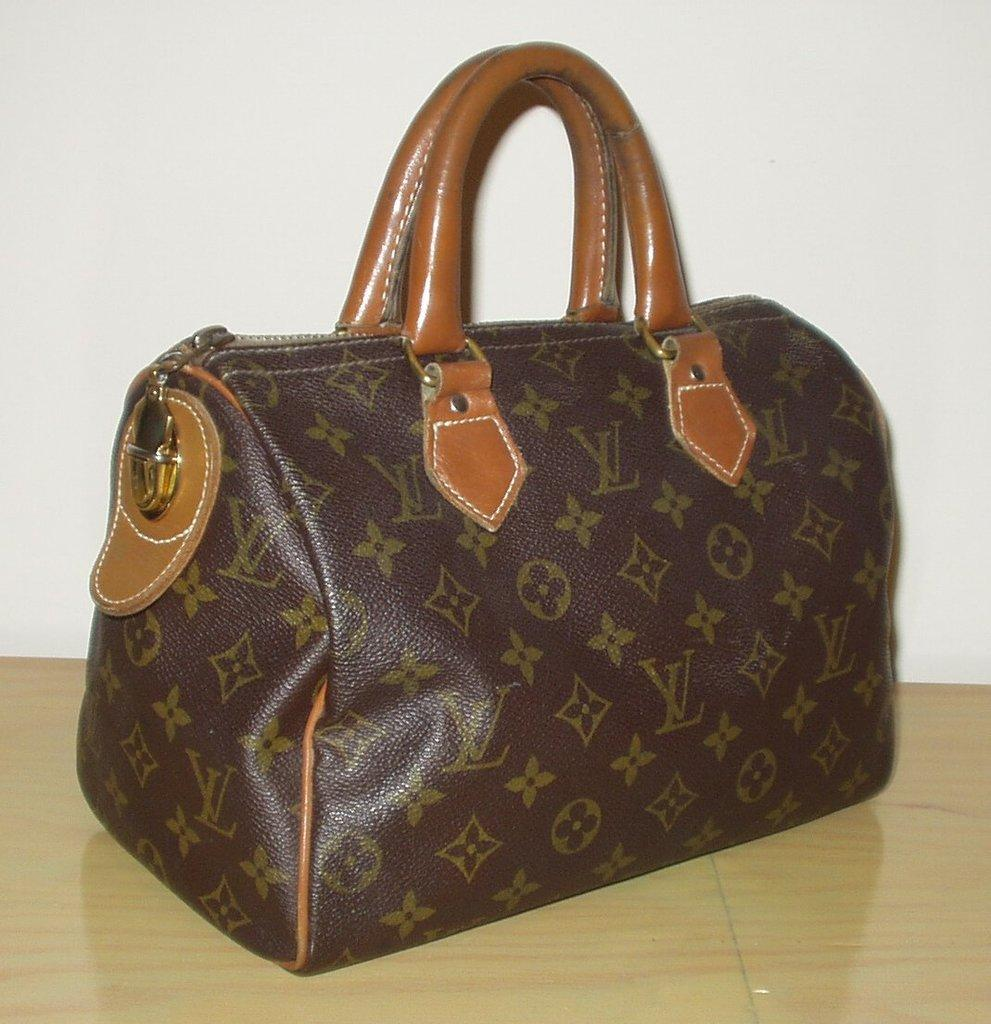What object is visible on the table in the image? There is a woman's handbag in the image. Where is the handbag located in relation to the table? The handbag is on the table. What type of substance is spilled on the table near the handbag? There is no substance spilled on the table near the handbag in the image. Is there a scarf draped over the handbag in the image? No, there is no scarf present in the image. 